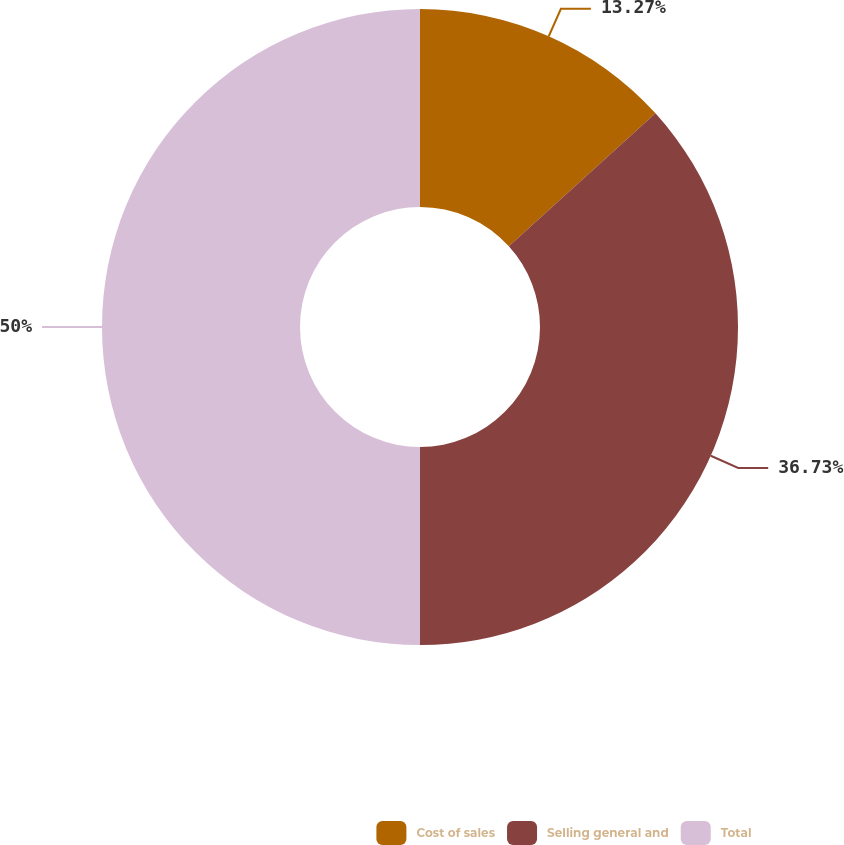Convert chart to OTSL. <chart><loc_0><loc_0><loc_500><loc_500><pie_chart><fcel>Cost of sales<fcel>Selling general and<fcel>Total<nl><fcel>13.27%<fcel>36.73%<fcel>50.0%<nl></chart> 